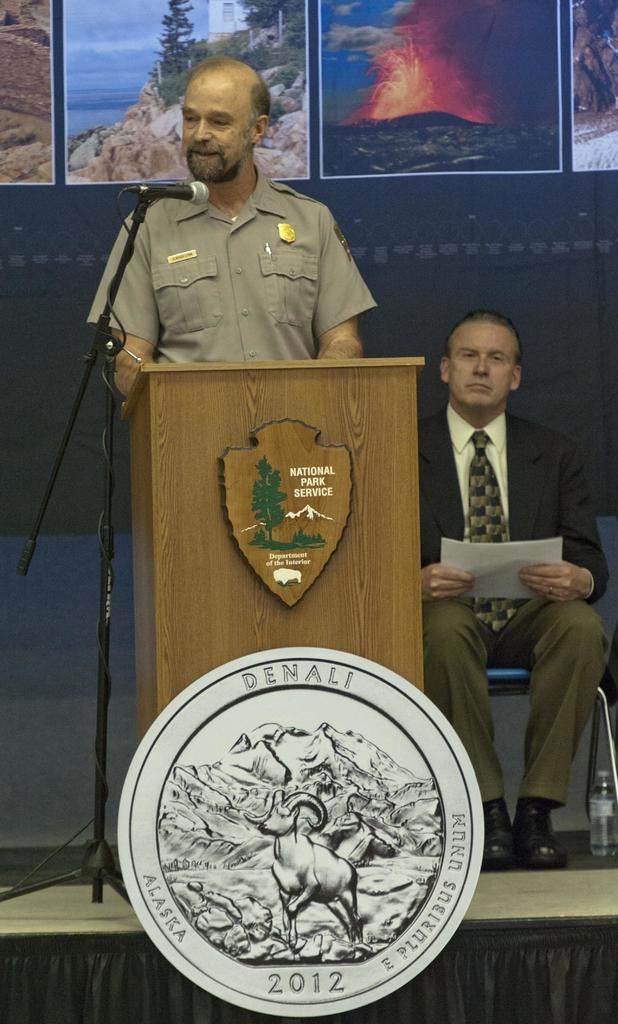<image>
Provide a brief description of the given image. a man from the national park service is giving a speech 